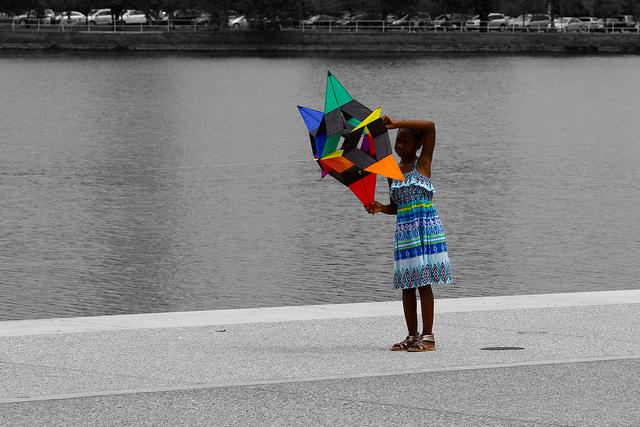Where does the girl want the toy she holds to go? Please explain your reasoning. skyward. Looks to be some kind of different shape kite. 